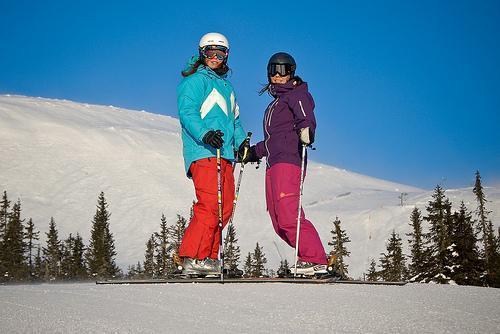How many people are there?
Give a very brief answer. 2. 